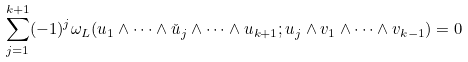<formula> <loc_0><loc_0><loc_500><loc_500>\sum _ { j = 1 } ^ { k + 1 } ( - 1 ) ^ { j } \omega _ { L } ( u _ { 1 } \land \dots \land \check { u } _ { j } \land \dots \land u _ { k + 1 } ; u _ { j } \land v _ { 1 } \land \dots \land v _ { k - 1 } ) = 0</formula> 